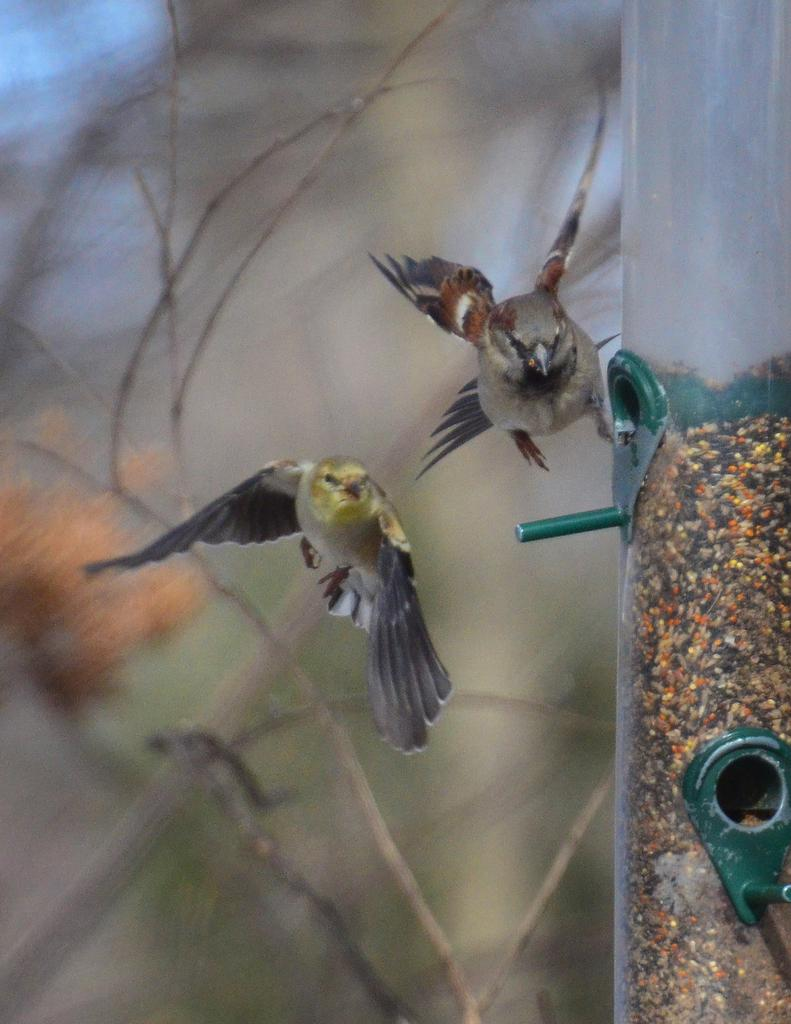What is the main object in the center of the image? There is a pole in the center of the image. What are the birds doing in the image? Two birds are flying in the image. What can be seen in the background of the image? There are trees visible in the background of the image. What type of drug can be seen in the image? There is no drug present in the image. 